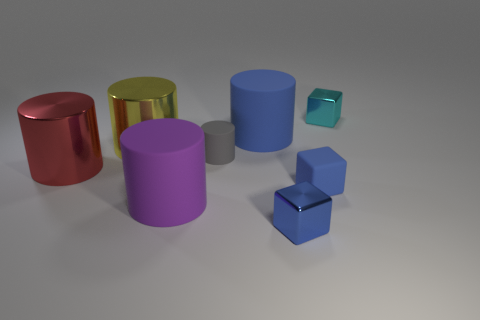Subtract all gray rubber cylinders. How many cylinders are left? 4 Subtract all yellow cylinders. How many cylinders are left? 4 Subtract all brown cylinders. Subtract all yellow cubes. How many cylinders are left? 5 Add 2 small gray cylinders. How many objects exist? 10 Subtract all cylinders. How many objects are left? 3 Subtract 1 blue cubes. How many objects are left? 7 Subtract all large purple things. Subtract all cylinders. How many objects are left? 2 Add 7 red cylinders. How many red cylinders are left? 8 Add 2 green metal cylinders. How many green metal cylinders exist? 2 